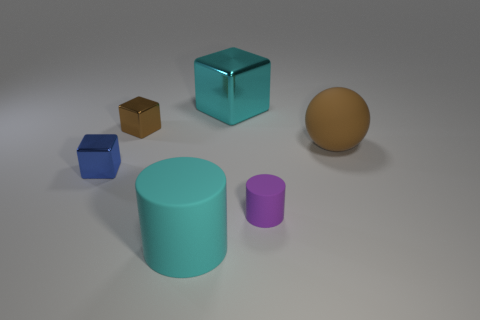Does the cube that is to the right of the small brown cube have the same size as the brown metal object behind the blue object?
Your response must be concise. No. There is a brown object that is the same shape as the big cyan metallic thing; what is its material?
Your response must be concise. Metal. What number of tiny objects are red cylinders or blue things?
Keep it short and to the point. 1. What is the material of the large cyan block?
Ensure brevity in your answer.  Metal. What is the object that is both to the right of the cyan cylinder and in front of the rubber sphere made of?
Provide a short and direct response. Rubber. There is a rubber ball; is its color the same as the small cube in front of the brown block?
Provide a succinct answer. No. There is a brown block that is the same size as the blue shiny cube; what is its material?
Offer a very short reply. Metal. Is there another cylinder made of the same material as the purple cylinder?
Give a very brief answer. Yes. What number of metallic blocks are there?
Make the answer very short. 3. Is the material of the small purple cylinder the same as the cyan object that is behind the tiny cylinder?
Your response must be concise. No. 